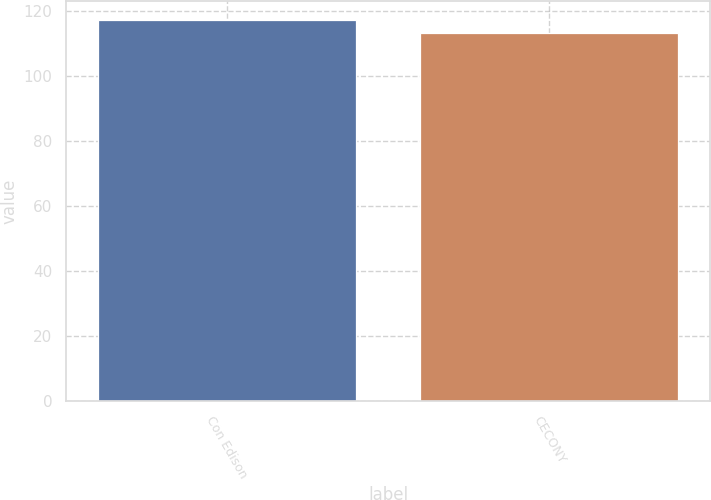Convert chart to OTSL. <chart><loc_0><loc_0><loc_500><loc_500><bar_chart><fcel>Con Edison<fcel>CECONY<nl><fcel>117<fcel>113<nl></chart> 